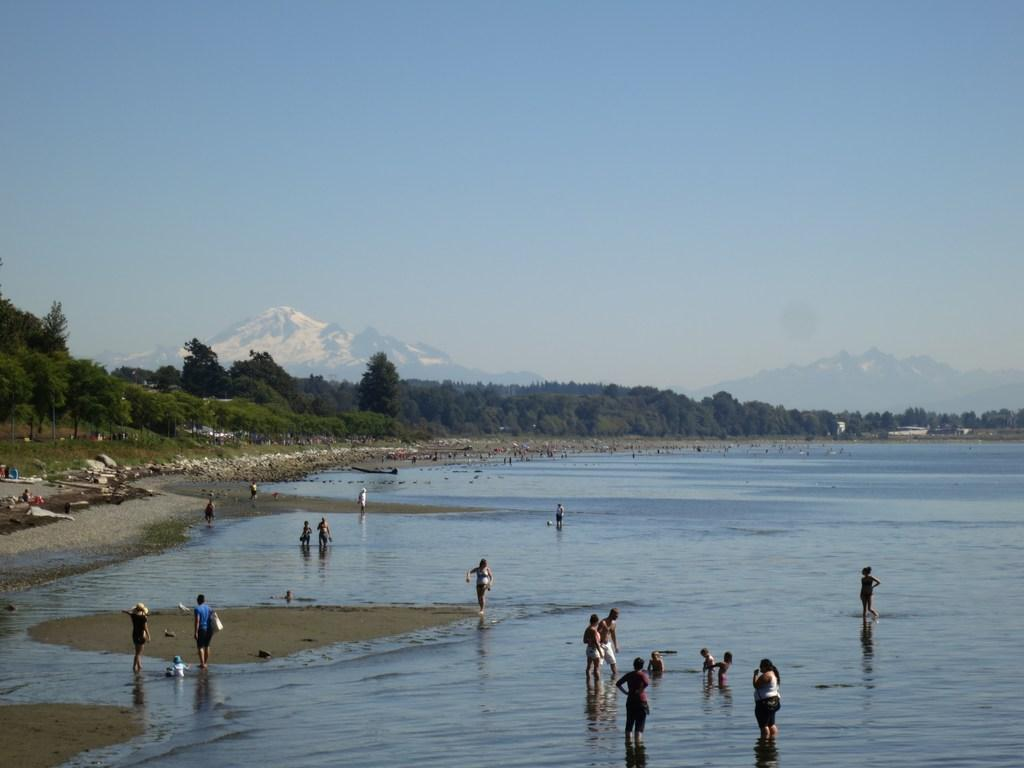What is the main element in the image? There is water in the image. What are the people in the image doing? There are people standing in the water. What can be seen on the bank of the water? There are trees on the bank of the water. What is visible in the background of the image? There are trees, mountains, and the sky visible in the background of the image. How many bedrooms can be seen in the image? There are no bedrooms present in the image. What type of amount is being measured in the image? There is no measurement or amount being depicted in the image. 